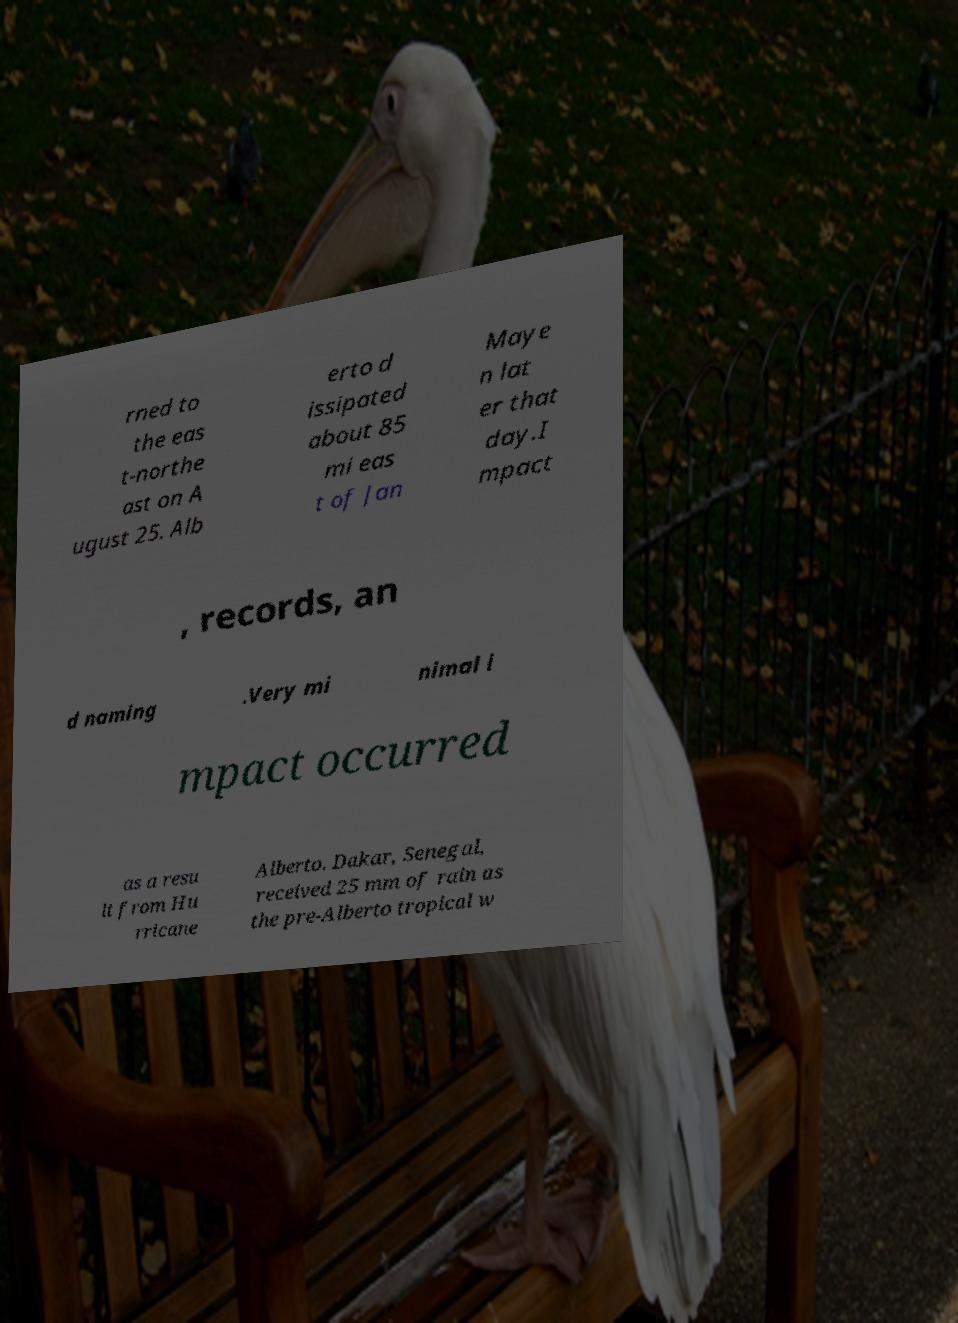Please read and relay the text visible in this image. What does it say? rned to the eas t-northe ast on A ugust 25. Alb erto d issipated about 85 mi eas t of Jan Maye n lat er that day.I mpact , records, an d naming .Very mi nimal i mpact occurred as a resu lt from Hu rricane Alberto. Dakar, Senegal, received 25 mm of rain as the pre-Alberto tropical w 